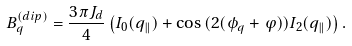Convert formula to latex. <formula><loc_0><loc_0><loc_500><loc_500>B ^ { ( d i p ) } _ { q } = \frac { 3 \pi J _ { d } } { 4 } \left ( I _ { 0 } ( q _ { \| } ) + \cos { ( 2 ( \phi _ { q } + \varphi ) ) } I _ { 2 } ( q _ { \| } ) \right ) .</formula> 